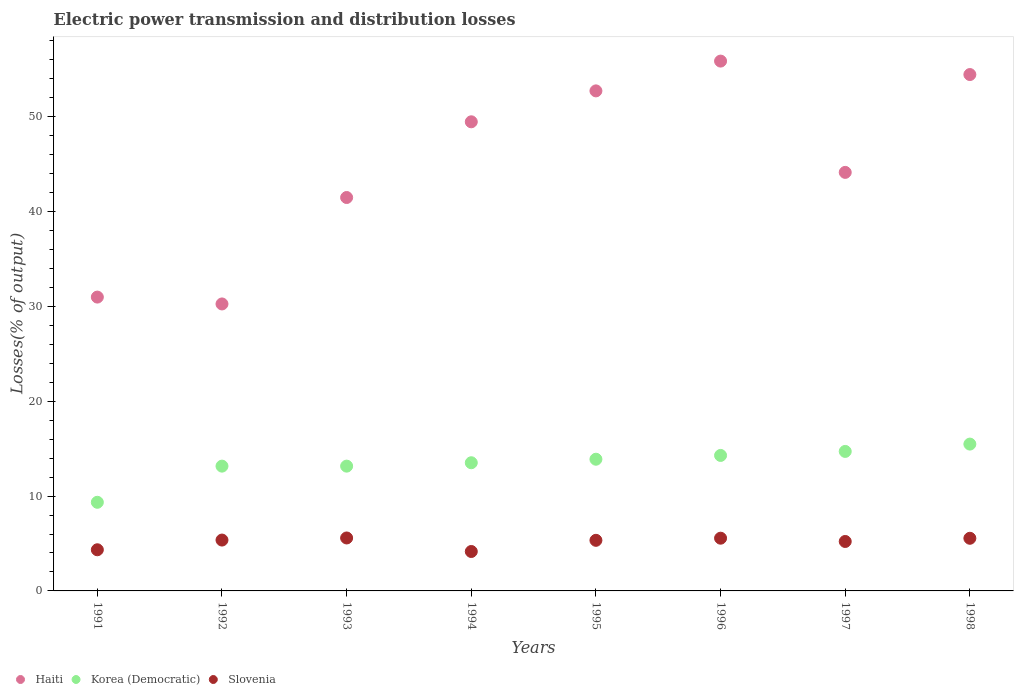How many different coloured dotlines are there?
Ensure brevity in your answer.  3. Is the number of dotlines equal to the number of legend labels?
Your answer should be very brief. Yes. What is the electric power transmission and distribution losses in Slovenia in 1991?
Offer a terse response. 4.34. Across all years, what is the maximum electric power transmission and distribution losses in Haiti?
Your response must be concise. 55.87. Across all years, what is the minimum electric power transmission and distribution losses in Haiti?
Give a very brief answer. 30.26. In which year was the electric power transmission and distribution losses in Slovenia maximum?
Make the answer very short. 1993. In which year was the electric power transmission and distribution losses in Slovenia minimum?
Make the answer very short. 1994. What is the total electric power transmission and distribution losses in Slovenia in the graph?
Offer a very short reply. 41.1. What is the difference between the electric power transmission and distribution losses in Slovenia in 1991 and that in 1995?
Your answer should be compact. -1. What is the difference between the electric power transmission and distribution losses in Korea (Democratic) in 1998 and the electric power transmission and distribution losses in Slovenia in 1992?
Your response must be concise. 10.12. What is the average electric power transmission and distribution losses in Korea (Democratic) per year?
Offer a very short reply. 13.44. In the year 1997, what is the difference between the electric power transmission and distribution losses in Korea (Democratic) and electric power transmission and distribution losses in Haiti?
Provide a succinct answer. -29.42. What is the ratio of the electric power transmission and distribution losses in Haiti in 1991 to that in 1998?
Your response must be concise. 0.57. Is the electric power transmission and distribution losses in Korea (Democratic) in 1991 less than that in 1995?
Ensure brevity in your answer.  Yes. What is the difference between the highest and the second highest electric power transmission and distribution losses in Slovenia?
Provide a succinct answer. 0.02. What is the difference between the highest and the lowest electric power transmission and distribution losses in Haiti?
Make the answer very short. 25.61. Does the electric power transmission and distribution losses in Haiti monotonically increase over the years?
Provide a succinct answer. No. Is the electric power transmission and distribution losses in Haiti strictly less than the electric power transmission and distribution losses in Slovenia over the years?
Provide a succinct answer. No. How many dotlines are there?
Provide a succinct answer. 3. How many years are there in the graph?
Give a very brief answer. 8. What is the difference between two consecutive major ticks on the Y-axis?
Make the answer very short. 10. Does the graph contain grids?
Make the answer very short. No. How many legend labels are there?
Your answer should be compact. 3. What is the title of the graph?
Your answer should be compact. Electric power transmission and distribution losses. What is the label or title of the X-axis?
Offer a very short reply. Years. What is the label or title of the Y-axis?
Your response must be concise. Losses(% of output). What is the Losses(% of output) of Haiti in 1991?
Make the answer very short. 30.98. What is the Losses(% of output) of Korea (Democratic) in 1991?
Provide a succinct answer. 9.35. What is the Losses(% of output) of Slovenia in 1991?
Ensure brevity in your answer.  4.34. What is the Losses(% of output) of Haiti in 1992?
Ensure brevity in your answer.  30.26. What is the Losses(% of output) of Korea (Democratic) in 1992?
Offer a terse response. 13.16. What is the Losses(% of output) of Slovenia in 1992?
Offer a terse response. 5.36. What is the Losses(% of output) of Haiti in 1993?
Offer a terse response. 41.48. What is the Losses(% of output) of Korea (Democratic) in 1993?
Provide a succinct answer. 13.16. What is the Losses(% of output) of Slovenia in 1993?
Ensure brevity in your answer.  5.58. What is the Losses(% of output) in Haiti in 1994?
Make the answer very short. 49.47. What is the Losses(% of output) in Korea (Democratic) in 1994?
Your answer should be compact. 13.52. What is the Losses(% of output) in Slovenia in 1994?
Keep it short and to the point. 4.16. What is the Losses(% of output) of Haiti in 1995?
Your answer should be compact. 52.73. What is the Losses(% of output) of Korea (Democratic) in 1995?
Your answer should be compact. 13.89. What is the Losses(% of output) in Slovenia in 1995?
Give a very brief answer. 5.34. What is the Losses(% of output) in Haiti in 1996?
Your answer should be very brief. 55.87. What is the Losses(% of output) of Korea (Democratic) in 1996?
Your response must be concise. 14.29. What is the Losses(% of output) in Slovenia in 1996?
Your answer should be very brief. 5.56. What is the Losses(% of output) in Haiti in 1997?
Offer a terse response. 44.13. What is the Losses(% of output) of Korea (Democratic) in 1997?
Provide a succinct answer. 14.71. What is the Losses(% of output) of Slovenia in 1997?
Your response must be concise. 5.21. What is the Losses(% of output) in Haiti in 1998?
Your answer should be very brief. 54.45. What is the Losses(% of output) in Korea (Democratic) in 1998?
Your answer should be very brief. 15.48. What is the Losses(% of output) of Slovenia in 1998?
Provide a succinct answer. 5.55. Across all years, what is the maximum Losses(% of output) in Haiti?
Your answer should be very brief. 55.87. Across all years, what is the maximum Losses(% of output) of Korea (Democratic)?
Your answer should be compact. 15.48. Across all years, what is the maximum Losses(% of output) of Slovenia?
Offer a very short reply. 5.58. Across all years, what is the minimum Losses(% of output) in Haiti?
Provide a succinct answer. 30.26. Across all years, what is the minimum Losses(% of output) of Korea (Democratic)?
Provide a short and direct response. 9.35. Across all years, what is the minimum Losses(% of output) of Slovenia?
Your response must be concise. 4.16. What is the total Losses(% of output) in Haiti in the graph?
Make the answer very short. 359.37. What is the total Losses(% of output) in Korea (Democratic) in the graph?
Provide a short and direct response. 107.54. What is the total Losses(% of output) of Slovenia in the graph?
Provide a succinct answer. 41.1. What is the difference between the Losses(% of output) in Haiti in 1991 and that in 1992?
Provide a short and direct response. 0.72. What is the difference between the Losses(% of output) of Korea (Democratic) in 1991 and that in 1992?
Give a very brief answer. -3.81. What is the difference between the Losses(% of output) in Slovenia in 1991 and that in 1992?
Provide a succinct answer. -1.02. What is the difference between the Losses(% of output) of Haiti in 1991 and that in 1993?
Give a very brief answer. -10.5. What is the difference between the Losses(% of output) in Korea (Democratic) in 1991 and that in 1993?
Make the answer very short. -3.81. What is the difference between the Losses(% of output) of Slovenia in 1991 and that in 1993?
Your answer should be very brief. -1.24. What is the difference between the Losses(% of output) of Haiti in 1991 and that in 1994?
Offer a very short reply. -18.48. What is the difference between the Losses(% of output) of Korea (Democratic) in 1991 and that in 1994?
Make the answer very short. -4.17. What is the difference between the Losses(% of output) of Slovenia in 1991 and that in 1994?
Your answer should be very brief. 0.18. What is the difference between the Losses(% of output) of Haiti in 1991 and that in 1995?
Provide a short and direct response. -21.74. What is the difference between the Losses(% of output) in Korea (Democratic) in 1991 and that in 1995?
Give a very brief answer. -4.54. What is the difference between the Losses(% of output) in Slovenia in 1991 and that in 1995?
Your answer should be very brief. -1. What is the difference between the Losses(% of output) in Haiti in 1991 and that in 1996?
Offer a very short reply. -24.88. What is the difference between the Losses(% of output) in Korea (Democratic) in 1991 and that in 1996?
Ensure brevity in your answer.  -4.94. What is the difference between the Losses(% of output) in Slovenia in 1991 and that in 1996?
Provide a short and direct response. -1.22. What is the difference between the Losses(% of output) in Haiti in 1991 and that in 1997?
Ensure brevity in your answer.  -13.15. What is the difference between the Losses(% of output) of Korea (Democratic) in 1991 and that in 1997?
Provide a short and direct response. -5.36. What is the difference between the Losses(% of output) in Slovenia in 1991 and that in 1997?
Provide a succinct answer. -0.87. What is the difference between the Losses(% of output) of Haiti in 1991 and that in 1998?
Provide a short and direct response. -23.47. What is the difference between the Losses(% of output) of Korea (Democratic) in 1991 and that in 1998?
Ensure brevity in your answer.  -6.14. What is the difference between the Losses(% of output) in Slovenia in 1991 and that in 1998?
Offer a terse response. -1.21. What is the difference between the Losses(% of output) of Haiti in 1992 and that in 1993?
Your response must be concise. -11.22. What is the difference between the Losses(% of output) in Korea (Democratic) in 1992 and that in 1993?
Give a very brief answer. -0. What is the difference between the Losses(% of output) in Slovenia in 1992 and that in 1993?
Keep it short and to the point. -0.22. What is the difference between the Losses(% of output) in Haiti in 1992 and that in 1994?
Keep it short and to the point. -19.21. What is the difference between the Losses(% of output) in Korea (Democratic) in 1992 and that in 1994?
Offer a terse response. -0.36. What is the difference between the Losses(% of output) in Slovenia in 1992 and that in 1994?
Give a very brief answer. 1.21. What is the difference between the Losses(% of output) of Haiti in 1992 and that in 1995?
Give a very brief answer. -22.47. What is the difference between the Losses(% of output) in Korea (Democratic) in 1992 and that in 1995?
Keep it short and to the point. -0.73. What is the difference between the Losses(% of output) of Slovenia in 1992 and that in 1995?
Provide a succinct answer. 0.03. What is the difference between the Losses(% of output) of Haiti in 1992 and that in 1996?
Provide a short and direct response. -25.61. What is the difference between the Losses(% of output) of Korea (Democratic) in 1992 and that in 1996?
Give a very brief answer. -1.13. What is the difference between the Losses(% of output) in Slovenia in 1992 and that in 1996?
Make the answer very short. -0.2. What is the difference between the Losses(% of output) in Haiti in 1992 and that in 1997?
Ensure brevity in your answer.  -13.87. What is the difference between the Losses(% of output) of Korea (Democratic) in 1992 and that in 1997?
Your answer should be very brief. -1.55. What is the difference between the Losses(% of output) of Slovenia in 1992 and that in 1997?
Give a very brief answer. 0.15. What is the difference between the Losses(% of output) of Haiti in 1992 and that in 1998?
Provide a short and direct response. -24.19. What is the difference between the Losses(% of output) in Korea (Democratic) in 1992 and that in 1998?
Your response must be concise. -2.32. What is the difference between the Losses(% of output) in Slovenia in 1992 and that in 1998?
Your response must be concise. -0.19. What is the difference between the Losses(% of output) of Haiti in 1993 and that in 1994?
Your answer should be very brief. -7.98. What is the difference between the Losses(% of output) in Korea (Democratic) in 1993 and that in 1994?
Your answer should be very brief. -0.36. What is the difference between the Losses(% of output) of Slovenia in 1993 and that in 1994?
Ensure brevity in your answer.  1.43. What is the difference between the Losses(% of output) of Haiti in 1993 and that in 1995?
Ensure brevity in your answer.  -11.24. What is the difference between the Losses(% of output) in Korea (Democratic) in 1993 and that in 1995?
Keep it short and to the point. -0.73. What is the difference between the Losses(% of output) of Slovenia in 1993 and that in 1995?
Your answer should be compact. 0.25. What is the difference between the Losses(% of output) of Haiti in 1993 and that in 1996?
Your answer should be very brief. -14.38. What is the difference between the Losses(% of output) in Korea (Democratic) in 1993 and that in 1996?
Provide a short and direct response. -1.13. What is the difference between the Losses(% of output) in Slovenia in 1993 and that in 1996?
Make the answer very short. 0.02. What is the difference between the Losses(% of output) of Haiti in 1993 and that in 1997?
Offer a terse response. -2.65. What is the difference between the Losses(% of output) of Korea (Democratic) in 1993 and that in 1997?
Ensure brevity in your answer.  -1.55. What is the difference between the Losses(% of output) of Slovenia in 1993 and that in 1997?
Provide a succinct answer. 0.37. What is the difference between the Losses(% of output) in Haiti in 1993 and that in 1998?
Give a very brief answer. -12.97. What is the difference between the Losses(% of output) in Korea (Democratic) in 1993 and that in 1998?
Provide a succinct answer. -2.32. What is the difference between the Losses(% of output) in Slovenia in 1993 and that in 1998?
Give a very brief answer. 0.03. What is the difference between the Losses(% of output) of Haiti in 1994 and that in 1995?
Give a very brief answer. -3.26. What is the difference between the Losses(% of output) in Korea (Democratic) in 1994 and that in 1995?
Make the answer very short. -0.37. What is the difference between the Losses(% of output) in Slovenia in 1994 and that in 1995?
Provide a short and direct response. -1.18. What is the difference between the Losses(% of output) of Haiti in 1994 and that in 1996?
Your answer should be very brief. -6.4. What is the difference between the Losses(% of output) of Korea (Democratic) in 1994 and that in 1996?
Your answer should be compact. -0.77. What is the difference between the Losses(% of output) in Slovenia in 1994 and that in 1996?
Offer a very short reply. -1.4. What is the difference between the Losses(% of output) in Haiti in 1994 and that in 1997?
Give a very brief answer. 5.33. What is the difference between the Losses(% of output) in Korea (Democratic) in 1994 and that in 1997?
Your answer should be very brief. -1.19. What is the difference between the Losses(% of output) in Slovenia in 1994 and that in 1997?
Your answer should be very brief. -1.06. What is the difference between the Losses(% of output) of Haiti in 1994 and that in 1998?
Offer a very short reply. -4.98. What is the difference between the Losses(% of output) of Korea (Democratic) in 1994 and that in 1998?
Your answer should be compact. -1.97. What is the difference between the Losses(% of output) of Slovenia in 1994 and that in 1998?
Your response must be concise. -1.39. What is the difference between the Losses(% of output) in Haiti in 1995 and that in 1996?
Keep it short and to the point. -3.14. What is the difference between the Losses(% of output) of Korea (Democratic) in 1995 and that in 1996?
Provide a short and direct response. -0.4. What is the difference between the Losses(% of output) of Slovenia in 1995 and that in 1996?
Your response must be concise. -0.22. What is the difference between the Losses(% of output) in Haiti in 1995 and that in 1997?
Make the answer very short. 8.6. What is the difference between the Losses(% of output) of Korea (Democratic) in 1995 and that in 1997?
Keep it short and to the point. -0.82. What is the difference between the Losses(% of output) in Slovenia in 1995 and that in 1997?
Your answer should be very brief. 0.12. What is the difference between the Losses(% of output) in Haiti in 1995 and that in 1998?
Keep it short and to the point. -1.72. What is the difference between the Losses(% of output) of Korea (Democratic) in 1995 and that in 1998?
Your response must be concise. -1.6. What is the difference between the Losses(% of output) in Slovenia in 1995 and that in 1998?
Keep it short and to the point. -0.21. What is the difference between the Losses(% of output) of Haiti in 1996 and that in 1997?
Offer a very short reply. 11.74. What is the difference between the Losses(% of output) of Korea (Democratic) in 1996 and that in 1997?
Offer a terse response. -0.42. What is the difference between the Losses(% of output) in Slovenia in 1996 and that in 1997?
Your answer should be very brief. 0.35. What is the difference between the Losses(% of output) of Haiti in 1996 and that in 1998?
Make the answer very short. 1.42. What is the difference between the Losses(% of output) of Korea (Democratic) in 1996 and that in 1998?
Your answer should be compact. -1.2. What is the difference between the Losses(% of output) in Slovenia in 1996 and that in 1998?
Provide a short and direct response. 0.01. What is the difference between the Losses(% of output) in Haiti in 1997 and that in 1998?
Keep it short and to the point. -10.32. What is the difference between the Losses(% of output) of Korea (Democratic) in 1997 and that in 1998?
Offer a terse response. -0.77. What is the difference between the Losses(% of output) in Slovenia in 1997 and that in 1998?
Provide a short and direct response. -0.34. What is the difference between the Losses(% of output) of Haiti in 1991 and the Losses(% of output) of Korea (Democratic) in 1992?
Keep it short and to the point. 17.82. What is the difference between the Losses(% of output) in Haiti in 1991 and the Losses(% of output) in Slovenia in 1992?
Give a very brief answer. 25.62. What is the difference between the Losses(% of output) in Korea (Democratic) in 1991 and the Losses(% of output) in Slovenia in 1992?
Provide a succinct answer. 3.98. What is the difference between the Losses(% of output) of Haiti in 1991 and the Losses(% of output) of Korea (Democratic) in 1993?
Your response must be concise. 17.82. What is the difference between the Losses(% of output) in Haiti in 1991 and the Losses(% of output) in Slovenia in 1993?
Offer a terse response. 25.4. What is the difference between the Losses(% of output) in Korea (Democratic) in 1991 and the Losses(% of output) in Slovenia in 1993?
Your answer should be compact. 3.76. What is the difference between the Losses(% of output) of Haiti in 1991 and the Losses(% of output) of Korea (Democratic) in 1994?
Offer a terse response. 17.47. What is the difference between the Losses(% of output) of Haiti in 1991 and the Losses(% of output) of Slovenia in 1994?
Your answer should be compact. 26.83. What is the difference between the Losses(% of output) in Korea (Democratic) in 1991 and the Losses(% of output) in Slovenia in 1994?
Offer a very short reply. 5.19. What is the difference between the Losses(% of output) in Haiti in 1991 and the Losses(% of output) in Korea (Democratic) in 1995?
Offer a terse response. 17.1. What is the difference between the Losses(% of output) in Haiti in 1991 and the Losses(% of output) in Slovenia in 1995?
Your answer should be very brief. 25.65. What is the difference between the Losses(% of output) of Korea (Democratic) in 1991 and the Losses(% of output) of Slovenia in 1995?
Offer a very short reply. 4.01. What is the difference between the Losses(% of output) of Haiti in 1991 and the Losses(% of output) of Korea (Democratic) in 1996?
Make the answer very short. 16.7. What is the difference between the Losses(% of output) of Haiti in 1991 and the Losses(% of output) of Slovenia in 1996?
Make the answer very short. 25.42. What is the difference between the Losses(% of output) of Korea (Democratic) in 1991 and the Losses(% of output) of Slovenia in 1996?
Ensure brevity in your answer.  3.79. What is the difference between the Losses(% of output) in Haiti in 1991 and the Losses(% of output) in Korea (Democratic) in 1997?
Keep it short and to the point. 16.27. What is the difference between the Losses(% of output) in Haiti in 1991 and the Losses(% of output) in Slovenia in 1997?
Ensure brevity in your answer.  25.77. What is the difference between the Losses(% of output) in Korea (Democratic) in 1991 and the Losses(% of output) in Slovenia in 1997?
Make the answer very short. 4.13. What is the difference between the Losses(% of output) of Haiti in 1991 and the Losses(% of output) of Korea (Democratic) in 1998?
Your response must be concise. 15.5. What is the difference between the Losses(% of output) in Haiti in 1991 and the Losses(% of output) in Slovenia in 1998?
Give a very brief answer. 25.43. What is the difference between the Losses(% of output) in Korea (Democratic) in 1991 and the Losses(% of output) in Slovenia in 1998?
Provide a succinct answer. 3.8. What is the difference between the Losses(% of output) of Haiti in 1992 and the Losses(% of output) of Korea (Democratic) in 1993?
Your answer should be very brief. 17.1. What is the difference between the Losses(% of output) of Haiti in 1992 and the Losses(% of output) of Slovenia in 1993?
Ensure brevity in your answer.  24.68. What is the difference between the Losses(% of output) in Korea (Democratic) in 1992 and the Losses(% of output) in Slovenia in 1993?
Ensure brevity in your answer.  7.57. What is the difference between the Losses(% of output) of Haiti in 1992 and the Losses(% of output) of Korea (Democratic) in 1994?
Your answer should be very brief. 16.74. What is the difference between the Losses(% of output) of Haiti in 1992 and the Losses(% of output) of Slovenia in 1994?
Give a very brief answer. 26.1. What is the difference between the Losses(% of output) in Korea (Democratic) in 1992 and the Losses(% of output) in Slovenia in 1994?
Keep it short and to the point. 9. What is the difference between the Losses(% of output) in Haiti in 1992 and the Losses(% of output) in Korea (Democratic) in 1995?
Make the answer very short. 16.37. What is the difference between the Losses(% of output) in Haiti in 1992 and the Losses(% of output) in Slovenia in 1995?
Offer a very short reply. 24.92. What is the difference between the Losses(% of output) of Korea (Democratic) in 1992 and the Losses(% of output) of Slovenia in 1995?
Offer a terse response. 7.82. What is the difference between the Losses(% of output) of Haiti in 1992 and the Losses(% of output) of Korea (Democratic) in 1996?
Your answer should be compact. 15.97. What is the difference between the Losses(% of output) of Haiti in 1992 and the Losses(% of output) of Slovenia in 1996?
Give a very brief answer. 24.7. What is the difference between the Losses(% of output) in Korea (Democratic) in 1992 and the Losses(% of output) in Slovenia in 1996?
Your answer should be compact. 7.6. What is the difference between the Losses(% of output) of Haiti in 1992 and the Losses(% of output) of Korea (Democratic) in 1997?
Give a very brief answer. 15.55. What is the difference between the Losses(% of output) in Haiti in 1992 and the Losses(% of output) in Slovenia in 1997?
Your response must be concise. 25.05. What is the difference between the Losses(% of output) in Korea (Democratic) in 1992 and the Losses(% of output) in Slovenia in 1997?
Make the answer very short. 7.94. What is the difference between the Losses(% of output) in Haiti in 1992 and the Losses(% of output) in Korea (Democratic) in 1998?
Make the answer very short. 14.78. What is the difference between the Losses(% of output) in Haiti in 1992 and the Losses(% of output) in Slovenia in 1998?
Offer a very short reply. 24.71. What is the difference between the Losses(% of output) in Korea (Democratic) in 1992 and the Losses(% of output) in Slovenia in 1998?
Provide a succinct answer. 7.61. What is the difference between the Losses(% of output) of Haiti in 1993 and the Losses(% of output) of Korea (Democratic) in 1994?
Your answer should be very brief. 27.97. What is the difference between the Losses(% of output) of Haiti in 1993 and the Losses(% of output) of Slovenia in 1994?
Ensure brevity in your answer.  37.33. What is the difference between the Losses(% of output) in Korea (Democratic) in 1993 and the Losses(% of output) in Slovenia in 1994?
Your answer should be compact. 9. What is the difference between the Losses(% of output) in Haiti in 1993 and the Losses(% of output) in Korea (Democratic) in 1995?
Ensure brevity in your answer.  27.6. What is the difference between the Losses(% of output) in Haiti in 1993 and the Losses(% of output) in Slovenia in 1995?
Give a very brief answer. 36.15. What is the difference between the Losses(% of output) in Korea (Democratic) in 1993 and the Losses(% of output) in Slovenia in 1995?
Give a very brief answer. 7.82. What is the difference between the Losses(% of output) of Haiti in 1993 and the Losses(% of output) of Korea (Democratic) in 1996?
Keep it short and to the point. 27.2. What is the difference between the Losses(% of output) in Haiti in 1993 and the Losses(% of output) in Slovenia in 1996?
Provide a succinct answer. 35.92. What is the difference between the Losses(% of output) in Korea (Democratic) in 1993 and the Losses(% of output) in Slovenia in 1996?
Give a very brief answer. 7.6. What is the difference between the Losses(% of output) of Haiti in 1993 and the Losses(% of output) of Korea (Democratic) in 1997?
Your response must be concise. 26.77. What is the difference between the Losses(% of output) in Haiti in 1993 and the Losses(% of output) in Slovenia in 1997?
Give a very brief answer. 36.27. What is the difference between the Losses(% of output) of Korea (Democratic) in 1993 and the Losses(% of output) of Slovenia in 1997?
Your response must be concise. 7.94. What is the difference between the Losses(% of output) in Haiti in 1993 and the Losses(% of output) in Korea (Democratic) in 1998?
Your answer should be compact. 26. What is the difference between the Losses(% of output) in Haiti in 1993 and the Losses(% of output) in Slovenia in 1998?
Give a very brief answer. 35.93. What is the difference between the Losses(% of output) in Korea (Democratic) in 1993 and the Losses(% of output) in Slovenia in 1998?
Keep it short and to the point. 7.61. What is the difference between the Losses(% of output) in Haiti in 1994 and the Losses(% of output) in Korea (Democratic) in 1995?
Make the answer very short. 35.58. What is the difference between the Losses(% of output) of Haiti in 1994 and the Losses(% of output) of Slovenia in 1995?
Provide a succinct answer. 44.13. What is the difference between the Losses(% of output) in Korea (Democratic) in 1994 and the Losses(% of output) in Slovenia in 1995?
Offer a very short reply. 8.18. What is the difference between the Losses(% of output) of Haiti in 1994 and the Losses(% of output) of Korea (Democratic) in 1996?
Keep it short and to the point. 35.18. What is the difference between the Losses(% of output) in Haiti in 1994 and the Losses(% of output) in Slovenia in 1996?
Give a very brief answer. 43.91. What is the difference between the Losses(% of output) in Korea (Democratic) in 1994 and the Losses(% of output) in Slovenia in 1996?
Your answer should be very brief. 7.95. What is the difference between the Losses(% of output) of Haiti in 1994 and the Losses(% of output) of Korea (Democratic) in 1997?
Ensure brevity in your answer.  34.76. What is the difference between the Losses(% of output) of Haiti in 1994 and the Losses(% of output) of Slovenia in 1997?
Your answer should be very brief. 44.25. What is the difference between the Losses(% of output) in Korea (Democratic) in 1994 and the Losses(% of output) in Slovenia in 1997?
Keep it short and to the point. 8.3. What is the difference between the Losses(% of output) in Haiti in 1994 and the Losses(% of output) in Korea (Democratic) in 1998?
Offer a terse response. 33.98. What is the difference between the Losses(% of output) of Haiti in 1994 and the Losses(% of output) of Slovenia in 1998?
Your response must be concise. 43.92. What is the difference between the Losses(% of output) of Korea (Democratic) in 1994 and the Losses(% of output) of Slovenia in 1998?
Make the answer very short. 7.96. What is the difference between the Losses(% of output) of Haiti in 1995 and the Losses(% of output) of Korea (Democratic) in 1996?
Make the answer very short. 38.44. What is the difference between the Losses(% of output) in Haiti in 1995 and the Losses(% of output) in Slovenia in 1996?
Offer a very short reply. 47.17. What is the difference between the Losses(% of output) of Korea (Democratic) in 1995 and the Losses(% of output) of Slovenia in 1996?
Give a very brief answer. 8.33. What is the difference between the Losses(% of output) of Haiti in 1995 and the Losses(% of output) of Korea (Democratic) in 1997?
Ensure brevity in your answer.  38.02. What is the difference between the Losses(% of output) in Haiti in 1995 and the Losses(% of output) in Slovenia in 1997?
Keep it short and to the point. 47.51. What is the difference between the Losses(% of output) in Korea (Democratic) in 1995 and the Losses(% of output) in Slovenia in 1997?
Keep it short and to the point. 8.67. What is the difference between the Losses(% of output) of Haiti in 1995 and the Losses(% of output) of Korea (Democratic) in 1998?
Offer a very short reply. 37.24. What is the difference between the Losses(% of output) in Haiti in 1995 and the Losses(% of output) in Slovenia in 1998?
Provide a succinct answer. 47.18. What is the difference between the Losses(% of output) of Korea (Democratic) in 1995 and the Losses(% of output) of Slovenia in 1998?
Ensure brevity in your answer.  8.34. What is the difference between the Losses(% of output) in Haiti in 1996 and the Losses(% of output) in Korea (Democratic) in 1997?
Your response must be concise. 41.16. What is the difference between the Losses(% of output) in Haiti in 1996 and the Losses(% of output) in Slovenia in 1997?
Provide a succinct answer. 50.65. What is the difference between the Losses(% of output) in Korea (Democratic) in 1996 and the Losses(% of output) in Slovenia in 1997?
Give a very brief answer. 9.07. What is the difference between the Losses(% of output) in Haiti in 1996 and the Losses(% of output) in Korea (Democratic) in 1998?
Your response must be concise. 40.39. What is the difference between the Losses(% of output) of Haiti in 1996 and the Losses(% of output) of Slovenia in 1998?
Your answer should be compact. 50.32. What is the difference between the Losses(% of output) in Korea (Democratic) in 1996 and the Losses(% of output) in Slovenia in 1998?
Ensure brevity in your answer.  8.74. What is the difference between the Losses(% of output) in Haiti in 1997 and the Losses(% of output) in Korea (Democratic) in 1998?
Your answer should be compact. 28.65. What is the difference between the Losses(% of output) in Haiti in 1997 and the Losses(% of output) in Slovenia in 1998?
Ensure brevity in your answer.  38.58. What is the difference between the Losses(% of output) in Korea (Democratic) in 1997 and the Losses(% of output) in Slovenia in 1998?
Your answer should be very brief. 9.16. What is the average Losses(% of output) in Haiti per year?
Ensure brevity in your answer.  44.92. What is the average Losses(% of output) of Korea (Democratic) per year?
Keep it short and to the point. 13.44. What is the average Losses(% of output) in Slovenia per year?
Give a very brief answer. 5.14. In the year 1991, what is the difference between the Losses(% of output) of Haiti and Losses(% of output) of Korea (Democratic)?
Your answer should be compact. 21.64. In the year 1991, what is the difference between the Losses(% of output) in Haiti and Losses(% of output) in Slovenia?
Your response must be concise. 26.64. In the year 1991, what is the difference between the Losses(% of output) in Korea (Democratic) and Losses(% of output) in Slovenia?
Keep it short and to the point. 5.01. In the year 1992, what is the difference between the Losses(% of output) of Haiti and Losses(% of output) of Korea (Democratic)?
Keep it short and to the point. 17.1. In the year 1992, what is the difference between the Losses(% of output) of Haiti and Losses(% of output) of Slovenia?
Offer a very short reply. 24.9. In the year 1992, what is the difference between the Losses(% of output) in Korea (Democratic) and Losses(% of output) in Slovenia?
Provide a short and direct response. 7.79. In the year 1993, what is the difference between the Losses(% of output) of Haiti and Losses(% of output) of Korea (Democratic)?
Your answer should be compact. 28.33. In the year 1993, what is the difference between the Losses(% of output) of Haiti and Losses(% of output) of Slovenia?
Give a very brief answer. 35.9. In the year 1993, what is the difference between the Losses(% of output) in Korea (Democratic) and Losses(% of output) in Slovenia?
Your answer should be compact. 7.57. In the year 1994, what is the difference between the Losses(% of output) of Haiti and Losses(% of output) of Korea (Democratic)?
Make the answer very short. 35.95. In the year 1994, what is the difference between the Losses(% of output) in Haiti and Losses(% of output) in Slovenia?
Your answer should be compact. 45.31. In the year 1994, what is the difference between the Losses(% of output) of Korea (Democratic) and Losses(% of output) of Slovenia?
Your answer should be compact. 9.36. In the year 1995, what is the difference between the Losses(% of output) of Haiti and Losses(% of output) of Korea (Democratic)?
Provide a short and direct response. 38.84. In the year 1995, what is the difference between the Losses(% of output) of Haiti and Losses(% of output) of Slovenia?
Provide a short and direct response. 47.39. In the year 1995, what is the difference between the Losses(% of output) in Korea (Democratic) and Losses(% of output) in Slovenia?
Your response must be concise. 8.55. In the year 1996, what is the difference between the Losses(% of output) of Haiti and Losses(% of output) of Korea (Democratic)?
Your answer should be compact. 41.58. In the year 1996, what is the difference between the Losses(% of output) in Haiti and Losses(% of output) in Slovenia?
Your answer should be very brief. 50.31. In the year 1996, what is the difference between the Losses(% of output) of Korea (Democratic) and Losses(% of output) of Slovenia?
Keep it short and to the point. 8.73. In the year 1997, what is the difference between the Losses(% of output) of Haiti and Losses(% of output) of Korea (Democratic)?
Keep it short and to the point. 29.42. In the year 1997, what is the difference between the Losses(% of output) of Haiti and Losses(% of output) of Slovenia?
Your response must be concise. 38.92. In the year 1997, what is the difference between the Losses(% of output) in Korea (Democratic) and Losses(% of output) in Slovenia?
Your response must be concise. 9.5. In the year 1998, what is the difference between the Losses(% of output) in Haiti and Losses(% of output) in Korea (Democratic)?
Your answer should be compact. 38.97. In the year 1998, what is the difference between the Losses(% of output) of Haiti and Losses(% of output) of Slovenia?
Offer a very short reply. 48.9. In the year 1998, what is the difference between the Losses(% of output) of Korea (Democratic) and Losses(% of output) of Slovenia?
Your answer should be compact. 9.93. What is the ratio of the Losses(% of output) in Haiti in 1991 to that in 1992?
Give a very brief answer. 1.02. What is the ratio of the Losses(% of output) of Korea (Democratic) in 1991 to that in 1992?
Offer a very short reply. 0.71. What is the ratio of the Losses(% of output) of Slovenia in 1991 to that in 1992?
Your answer should be very brief. 0.81. What is the ratio of the Losses(% of output) of Haiti in 1991 to that in 1993?
Give a very brief answer. 0.75. What is the ratio of the Losses(% of output) in Korea (Democratic) in 1991 to that in 1993?
Keep it short and to the point. 0.71. What is the ratio of the Losses(% of output) in Slovenia in 1991 to that in 1993?
Your answer should be compact. 0.78. What is the ratio of the Losses(% of output) in Haiti in 1991 to that in 1994?
Ensure brevity in your answer.  0.63. What is the ratio of the Losses(% of output) of Korea (Democratic) in 1991 to that in 1994?
Provide a short and direct response. 0.69. What is the ratio of the Losses(% of output) in Slovenia in 1991 to that in 1994?
Provide a succinct answer. 1.04. What is the ratio of the Losses(% of output) of Haiti in 1991 to that in 1995?
Ensure brevity in your answer.  0.59. What is the ratio of the Losses(% of output) of Korea (Democratic) in 1991 to that in 1995?
Give a very brief answer. 0.67. What is the ratio of the Losses(% of output) of Slovenia in 1991 to that in 1995?
Make the answer very short. 0.81. What is the ratio of the Losses(% of output) in Haiti in 1991 to that in 1996?
Make the answer very short. 0.55. What is the ratio of the Losses(% of output) of Korea (Democratic) in 1991 to that in 1996?
Ensure brevity in your answer.  0.65. What is the ratio of the Losses(% of output) in Slovenia in 1991 to that in 1996?
Your answer should be compact. 0.78. What is the ratio of the Losses(% of output) of Haiti in 1991 to that in 1997?
Provide a short and direct response. 0.7. What is the ratio of the Losses(% of output) in Korea (Democratic) in 1991 to that in 1997?
Make the answer very short. 0.64. What is the ratio of the Losses(% of output) of Slovenia in 1991 to that in 1997?
Make the answer very short. 0.83. What is the ratio of the Losses(% of output) of Haiti in 1991 to that in 1998?
Keep it short and to the point. 0.57. What is the ratio of the Losses(% of output) in Korea (Democratic) in 1991 to that in 1998?
Keep it short and to the point. 0.6. What is the ratio of the Losses(% of output) in Slovenia in 1991 to that in 1998?
Your answer should be compact. 0.78. What is the ratio of the Losses(% of output) in Haiti in 1992 to that in 1993?
Your answer should be very brief. 0.73. What is the ratio of the Losses(% of output) of Korea (Democratic) in 1992 to that in 1993?
Make the answer very short. 1. What is the ratio of the Losses(% of output) of Slovenia in 1992 to that in 1993?
Give a very brief answer. 0.96. What is the ratio of the Losses(% of output) in Haiti in 1992 to that in 1994?
Provide a succinct answer. 0.61. What is the ratio of the Losses(% of output) in Korea (Democratic) in 1992 to that in 1994?
Give a very brief answer. 0.97. What is the ratio of the Losses(% of output) of Slovenia in 1992 to that in 1994?
Your response must be concise. 1.29. What is the ratio of the Losses(% of output) in Haiti in 1992 to that in 1995?
Keep it short and to the point. 0.57. What is the ratio of the Losses(% of output) of Korea (Democratic) in 1992 to that in 1995?
Offer a terse response. 0.95. What is the ratio of the Losses(% of output) of Slovenia in 1992 to that in 1995?
Ensure brevity in your answer.  1.01. What is the ratio of the Losses(% of output) of Haiti in 1992 to that in 1996?
Give a very brief answer. 0.54. What is the ratio of the Losses(% of output) of Korea (Democratic) in 1992 to that in 1996?
Provide a short and direct response. 0.92. What is the ratio of the Losses(% of output) of Slovenia in 1992 to that in 1996?
Ensure brevity in your answer.  0.96. What is the ratio of the Losses(% of output) in Haiti in 1992 to that in 1997?
Your answer should be very brief. 0.69. What is the ratio of the Losses(% of output) in Korea (Democratic) in 1992 to that in 1997?
Your answer should be very brief. 0.89. What is the ratio of the Losses(% of output) of Slovenia in 1992 to that in 1997?
Make the answer very short. 1.03. What is the ratio of the Losses(% of output) of Haiti in 1992 to that in 1998?
Provide a succinct answer. 0.56. What is the ratio of the Losses(% of output) of Korea (Democratic) in 1992 to that in 1998?
Provide a short and direct response. 0.85. What is the ratio of the Losses(% of output) in Slovenia in 1992 to that in 1998?
Keep it short and to the point. 0.97. What is the ratio of the Losses(% of output) of Haiti in 1993 to that in 1994?
Your answer should be compact. 0.84. What is the ratio of the Losses(% of output) of Korea (Democratic) in 1993 to that in 1994?
Your answer should be very brief. 0.97. What is the ratio of the Losses(% of output) of Slovenia in 1993 to that in 1994?
Give a very brief answer. 1.34. What is the ratio of the Losses(% of output) in Haiti in 1993 to that in 1995?
Your response must be concise. 0.79. What is the ratio of the Losses(% of output) in Korea (Democratic) in 1993 to that in 1995?
Your answer should be very brief. 0.95. What is the ratio of the Losses(% of output) of Slovenia in 1993 to that in 1995?
Offer a terse response. 1.05. What is the ratio of the Losses(% of output) of Haiti in 1993 to that in 1996?
Your response must be concise. 0.74. What is the ratio of the Losses(% of output) in Korea (Democratic) in 1993 to that in 1996?
Your answer should be compact. 0.92. What is the ratio of the Losses(% of output) of Haiti in 1993 to that in 1997?
Your answer should be compact. 0.94. What is the ratio of the Losses(% of output) in Korea (Democratic) in 1993 to that in 1997?
Make the answer very short. 0.89. What is the ratio of the Losses(% of output) in Slovenia in 1993 to that in 1997?
Offer a terse response. 1.07. What is the ratio of the Losses(% of output) of Haiti in 1993 to that in 1998?
Give a very brief answer. 0.76. What is the ratio of the Losses(% of output) of Korea (Democratic) in 1993 to that in 1998?
Your response must be concise. 0.85. What is the ratio of the Losses(% of output) of Slovenia in 1993 to that in 1998?
Your answer should be very brief. 1.01. What is the ratio of the Losses(% of output) of Haiti in 1994 to that in 1995?
Keep it short and to the point. 0.94. What is the ratio of the Losses(% of output) of Korea (Democratic) in 1994 to that in 1995?
Offer a terse response. 0.97. What is the ratio of the Losses(% of output) of Slovenia in 1994 to that in 1995?
Ensure brevity in your answer.  0.78. What is the ratio of the Losses(% of output) in Haiti in 1994 to that in 1996?
Your answer should be very brief. 0.89. What is the ratio of the Losses(% of output) in Korea (Democratic) in 1994 to that in 1996?
Provide a short and direct response. 0.95. What is the ratio of the Losses(% of output) of Slovenia in 1994 to that in 1996?
Provide a short and direct response. 0.75. What is the ratio of the Losses(% of output) of Haiti in 1994 to that in 1997?
Keep it short and to the point. 1.12. What is the ratio of the Losses(% of output) of Korea (Democratic) in 1994 to that in 1997?
Give a very brief answer. 0.92. What is the ratio of the Losses(% of output) of Slovenia in 1994 to that in 1997?
Make the answer very short. 0.8. What is the ratio of the Losses(% of output) in Haiti in 1994 to that in 1998?
Offer a terse response. 0.91. What is the ratio of the Losses(% of output) in Korea (Democratic) in 1994 to that in 1998?
Ensure brevity in your answer.  0.87. What is the ratio of the Losses(% of output) in Slovenia in 1994 to that in 1998?
Ensure brevity in your answer.  0.75. What is the ratio of the Losses(% of output) of Haiti in 1995 to that in 1996?
Offer a very short reply. 0.94. What is the ratio of the Losses(% of output) in Slovenia in 1995 to that in 1996?
Give a very brief answer. 0.96. What is the ratio of the Losses(% of output) in Haiti in 1995 to that in 1997?
Offer a very short reply. 1.19. What is the ratio of the Losses(% of output) of Korea (Democratic) in 1995 to that in 1997?
Provide a succinct answer. 0.94. What is the ratio of the Losses(% of output) in Slovenia in 1995 to that in 1997?
Your answer should be very brief. 1.02. What is the ratio of the Losses(% of output) in Haiti in 1995 to that in 1998?
Make the answer very short. 0.97. What is the ratio of the Losses(% of output) in Korea (Democratic) in 1995 to that in 1998?
Your answer should be very brief. 0.9. What is the ratio of the Losses(% of output) of Slovenia in 1995 to that in 1998?
Provide a short and direct response. 0.96. What is the ratio of the Losses(% of output) of Haiti in 1996 to that in 1997?
Provide a succinct answer. 1.27. What is the ratio of the Losses(% of output) in Korea (Democratic) in 1996 to that in 1997?
Your answer should be very brief. 0.97. What is the ratio of the Losses(% of output) of Slovenia in 1996 to that in 1997?
Your response must be concise. 1.07. What is the ratio of the Losses(% of output) in Korea (Democratic) in 1996 to that in 1998?
Ensure brevity in your answer.  0.92. What is the ratio of the Losses(% of output) in Haiti in 1997 to that in 1998?
Give a very brief answer. 0.81. What is the ratio of the Losses(% of output) of Korea (Democratic) in 1997 to that in 1998?
Provide a succinct answer. 0.95. What is the ratio of the Losses(% of output) of Slovenia in 1997 to that in 1998?
Give a very brief answer. 0.94. What is the difference between the highest and the second highest Losses(% of output) in Haiti?
Offer a very short reply. 1.42. What is the difference between the highest and the second highest Losses(% of output) in Korea (Democratic)?
Provide a short and direct response. 0.77. What is the difference between the highest and the second highest Losses(% of output) of Slovenia?
Your response must be concise. 0.02. What is the difference between the highest and the lowest Losses(% of output) of Haiti?
Provide a short and direct response. 25.61. What is the difference between the highest and the lowest Losses(% of output) in Korea (Democratic)?
Give a very brief answer. 6.14. What is the difference between the highest and the lowest Losses(% of output) of Slovenia?
Offer a very short reply. 1.43. 